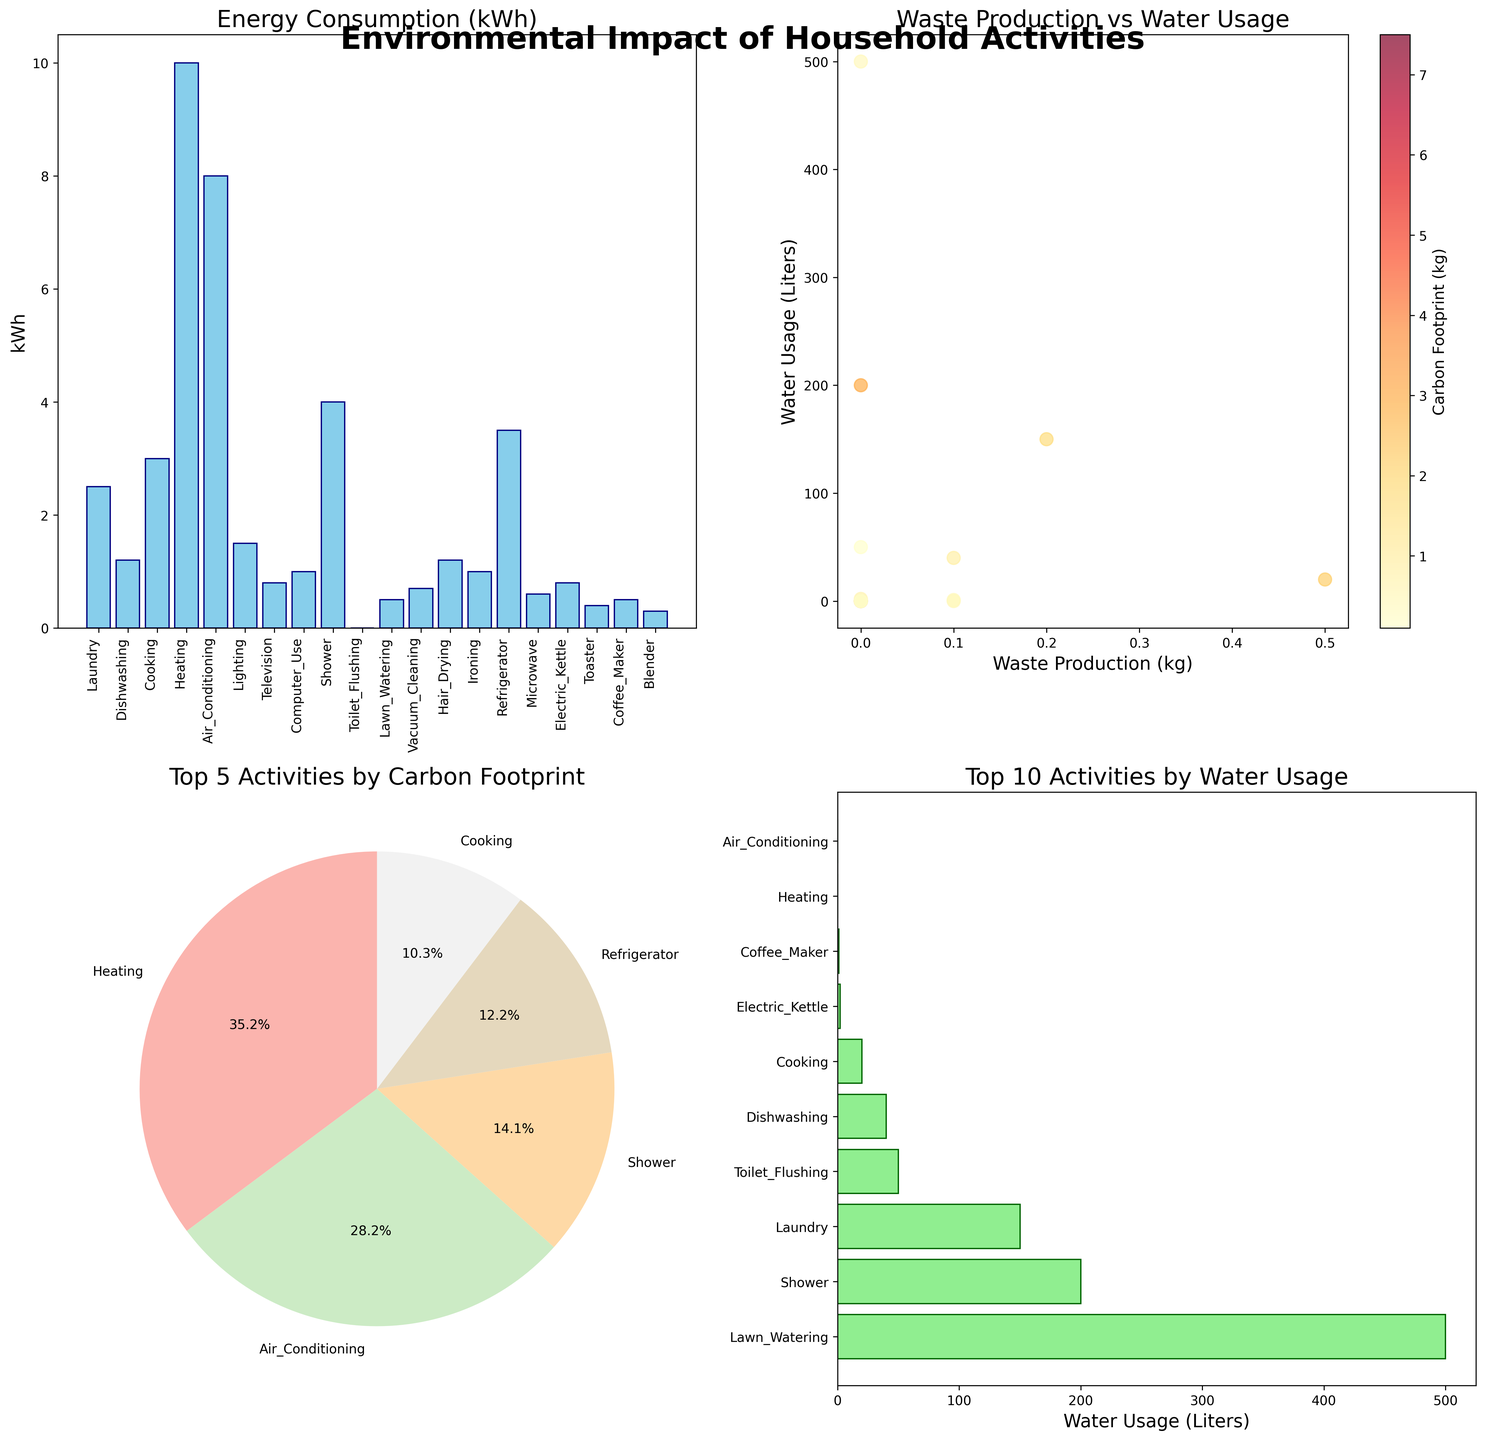What activity has the highest energy consumption? By looking at the bar plot labeled 'Energy Consumption (kWh)' on the top left subplot, we can see that Heating has the tallest bar, indicating the highest energy consumption
Answer: Heating Which activities are included in the top 5 by carbon footprint and what is their order? The pie chart on the bottom left subplot shows the top 5 activities by carbon footprint. The sectors of the pie chart are labeled with the activities and the corresponding percentages. From the chart, we can list the activities in descending order of their carbon footprint: Heating, Air Conditioning, Shower, Refrigerator, and Cooking
Answer: Heating, Air Conditioning, Shower, Refrigerator, Cooking How does waste production correlate with water usage? The scatter plot in the top right subplot shows the relationship between waste production (x-axis) and water usage (y-axis). By observing the plot, we can see that as waste production increases, water usage doesn't show a clear trend of increasing or decreasing, indicating no strong correlation between these variables
Answer: No strong correlation What is the total water usage of the top 3 activities? From the horizontal bar chart in the bottom right subplot, we can identify the top 3 activities by water usage: Lawn Watering (500 liters), Shower (200 liters), and Laundry (150 liters). Summing these values gives: 500 + 200 + 150 = 850 liters
Answer: 850 liters How does the carbon footprint of using a computer compare to using a television? Referring to the bar plot labeled 'Energy Consumption (kWh)' and correlating it with carbon footprint, or directly observing the pie chart which might show computer and television usage, we see that the bar plot shows slightly lower energy usage for television and also specifying the carbon footprint values directly in the data, Computer_Use (0.7 kg) has a slightly higher carbon footprint than Television (0.6 kg)
Answer: Computer_Use > Television What is the total waste production for Laundry and Coffee Maker? Looking at the individual bars for Laundry (0.2 kg) and Coffee Maker (0.1 kg) in the top left bar plot, we sum these values: 0.2 + 0.1 = 0.3 kg
Answer: 0.3 kg Which activity produces the least waste? The scatter plot in the top right subplot indicates the activities and waste production values. Activities like Heating, Air Conditioning, Lighting, Television, Computer Use, Shower, Toilet Flushing, Lawn Watering, Hair Drying, Ironing, Refrigerator, Microwave, Electric Kettle, Toaster, and Blender produce zero waste.
Answer: Heating (or any other mentioned) What is the ratio of energy consumption between Hair Drying and Ironing? From the bar plot for 'Energy Consumption (kWh)' on the top left, the energy consumption for Hair Drying is 1.2 kWh and for Ironing is 1 kWh. The ratio is calculated as Hair Drying / Ironing = 1.2 / 1 = 1.2
Answer: 1.2 How much more water does Lawn Watering use compared to Toilet Flushing? The horizontal bar chart for 'Top 10 Activities by Water Usage' indicates Lawn Watering uses 500 liters and Toilet Flushing uses 50 liters. The difference is calculated as 500 - 50 = 450 liters
Answer: 450 liters 